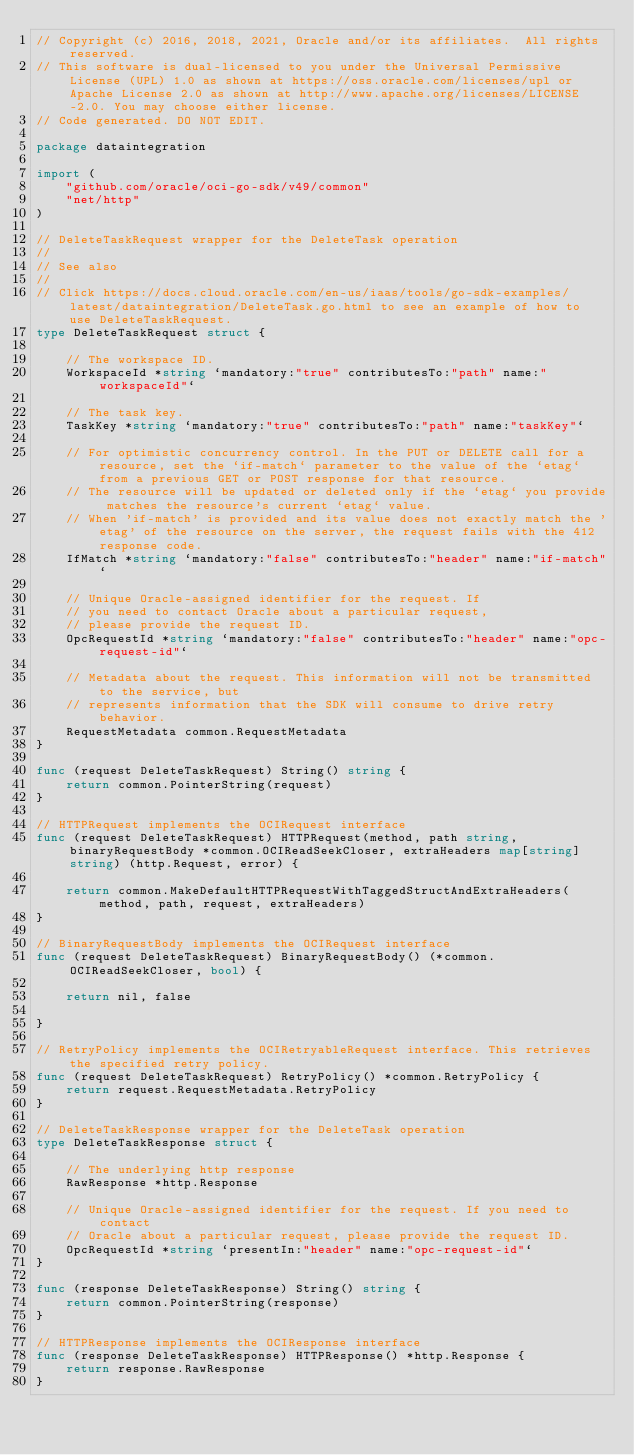<code> <loc_0><loc_0><loc_500><loc_500><_Go_>// Copyright (c) 2016, 2018, 2021, Oracle and/or its affiliates.  All rights reserved.
// This software is dual-licensed to you under the Universal Permissive License (UPL) 1.0 as shown at https://oss.oracle.com/licenses/upl or Apache License 2.0 as shown at http://www.apache.org/licenses/LICENSE-2.0. You may choose either license.
// Code generated. DO NOT EDIT.

package dataintegration

import (
	"github.com/oracle/oci-go-sdk/v49/common"
	"net/http"
)

// DeleteTaskRequest wrapper for the DeleteTask operation
//
// See also
//
// Click https://docs.cloud.oracle.com/en-us/iaas/tools/go-sdk-examples/latest/dataintegration/DeleteTask.go.html to see an example of how to use DeleteTaskRequest.
type DeleteTaskRequest struct {

	// The workspace ID.
	WorkspaceId *string `mandatory:"true" contributesTo:"path" name:"workspaceId"`

	// The task key.
	TaskKey *string `mandatory:"true" contributesTo:"path" name:"taskKey"`

	// For optimistic concurrency control. In the PUT or DELETE call for a resource, set the `if-match` parameter to the value of the `etag` from a previous GET or POST response for that resource.
	// The resource will be updated or deleted only if the `etag` you provide matches the resource's current `etag` value.
	// When 'if-match' is provided and its value does not exactly match the 'etag' of the resource on the server, the request fails with the 412 response code.
	IfMatch *string `mandatory:"false" contributesTo:"header" name:"if-match"`

	// Unique Oracle-assigned identifier for the request. If
	// you need to contact Oracle about a particular request,
	// please provide the request ID.
	OpcRequestId *string `mandatory:"false" contributesTo:"header" name:"opc-request-id"`

	// Metadata about the request. This information will not be transmitted to the service, but
	// represents information that the SDK will consume to drive retry behavior.
	RequestMetadata common.RequestMetadata
}

func (request DeleteTaskRequest) String() string {
	return common.PointerString(request)
}

// HTTPRequest implements the OCIRequest interface
func (request DeleteTaskRequest) HTTPRequest(method, path string, binaryRequestBody *common.OCIReadSeekCloser, extraHeaders map[string]string) (http.Request, error) {

	return common.MakeDefaultHTTPRequestWithTaggedStructAndExtraHeaders(method, path, request, extraHeaders)
}

// BinaryRequestBody implements the OCIRequest interface
func (request DeleteTaskRequest) BinaryRequestBody() (*common.OCIReadSeekCloser, bool) {

	return nil, false

}

// RetryPolicy implements the OCIRetryableRequest interface. This retrieves the specified retry policy.
func (request DeleteTaskRequest) RetryPolicy() *common.RetryPolicy {
	return request.RequestMetadata.RetryPolicy
}

// DeleteTaskResponse wrapper for the DeleteTask operation
type DeleteTaskResponse struct {

	// The underlying http response
	RawResponse *http.Response

	// Unique Oracle-assigned identifier for the request. If you need to contact
	// Oracle about a particular request, please provide the request ID.
	OpcRequestId *string `presentIn:"header" name:"opc-request-id"`
}

func (response DeleteTaskResponse) String() string {
	return common.PointerString(response)
}

// HTTPResponse implements the OCIResponse interface
func (response DeleteTaskResponse) HTTPResponse() *http.Response {
	return response.RawResponse
}
</code> 